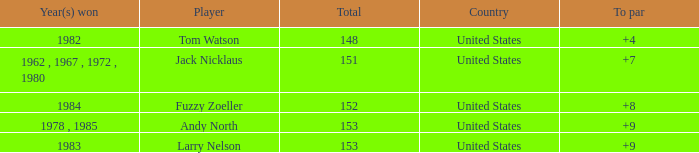What is the To par of Player Andy North with a Total larger than 153? 0.0. 